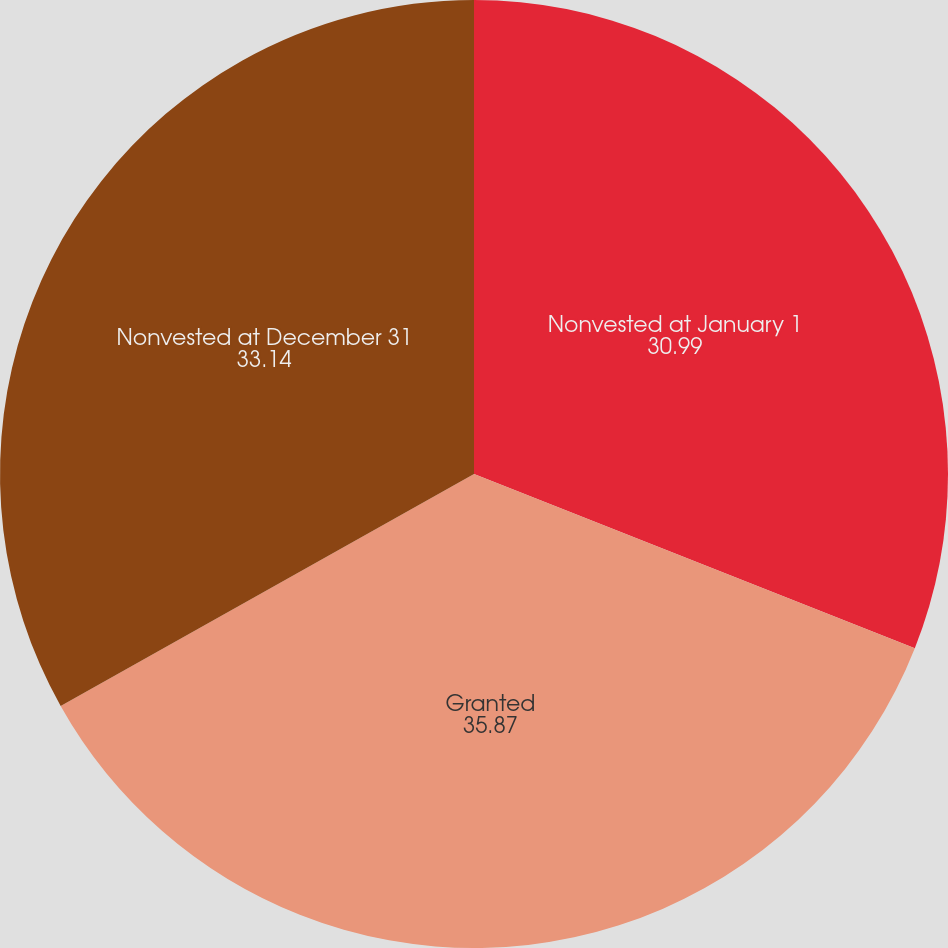Convert chart. <chart><loc_0><loc_0><loc_500><loc_500><pie_chart><fcel>Nonvested at January 1<fcel>Granted<fcel>Nonvested at December 31<nl><fcel>30.99%<fcel>35.87%<fcel>33.14%<nl></chart> 